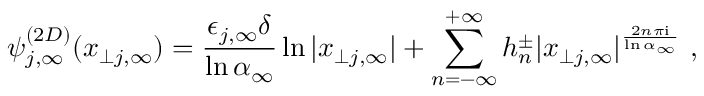<formula> <loc_0><loc_0><loc_500><loc_500>\psi _ { j , \infty } ^ { ( 2 D ) } ( x _ { \perp j , \infty } ) = \frac { \epsilon _ { j , \infty } \delta } { \ln \alpha _ { \infty } } \ln | x _ { \perp j , \infty } | + \sum _ { n = - \infty } ^ { + \infty } h _ { n } ^ { \pm } | x _ { \perp j , \infty } | ^ { \frac { 2 n \pi i } { \ln \alpha _ { \infty } } } ,</formula> 